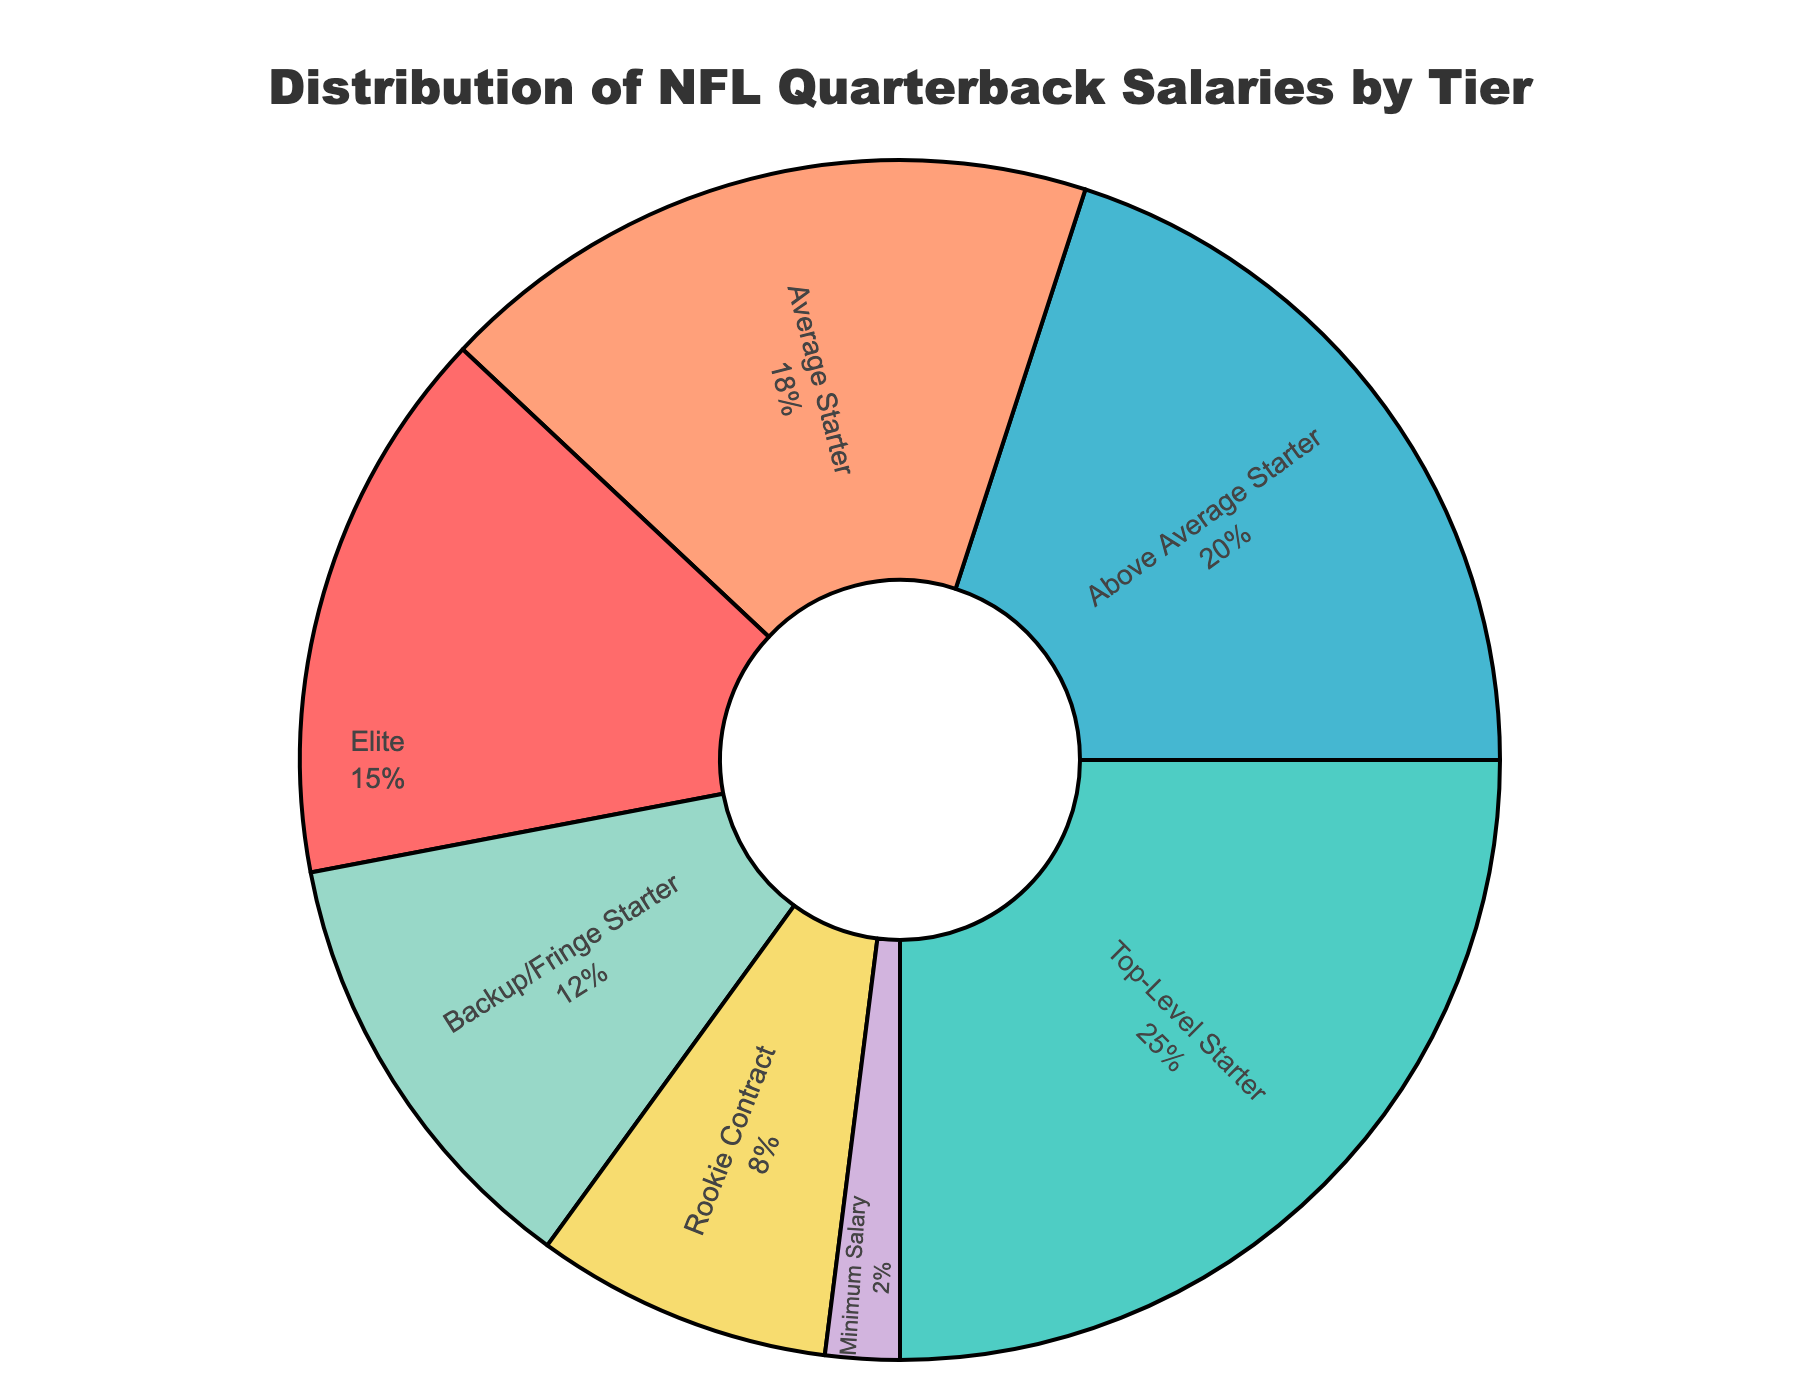What percentage of quarterbacks earn elite salaries? The segment labeled "Elite" represents 15% of the total quarterback salaries. We can observe this by looking at the segment labeled "Elite" in the pie chart.
Answer: 15% Which tier has the highest percentage of quarterback salaries? The segment labeled "Top-Level Starter" has the largest section of the pie chart, representing 25% of the total quarterback salaries. This is the highest percentage among all segments.
Answer: Top-Level Starter What is the combined percentage of quarterbacks earning rookie contract and minimum salary? The "Rookie Contract" segment represents 8% and "Minimum Salary" segment represents 2%. Adding these percentages together, we get 8% + 2% = 10%.
Answer: 10% How much more is the percentage of top-level starters compared to backup/fringe starters? The "Top-Level Starter" segment represents 25%, while the "Backup/Fringe Starter" segment represents 12%. Subtracting these, we get 25% - 12% = 13%.
Answer: 13% What percentage of quarterbacks earn salaries as above-average starters and average starters combined? The segments for "Above Average Starter" and "Average Starter" represent 20% and 18% respectively. Adding these percentages together, we get 20% + 18% = 38%.
Answer: 38% Which player is an example of an average starter, and what is the percentage of quarterbacks in this tier? The "Average Starter" segment is represented by 18%, and the example player for this tier is Jimmy Garoppolo, as labeled on the pie chart.
Answer: Jimmy Garoppolo, 18% Which tier has the smallest percentage of quarterback salaries? The "Minimum Salary" segment has the smallest section of the pie chart, representing only 2% of the total quarterback salaries.
Answer: Minimum Salary Is the total percentage of quarterbacks earning salaries below above-average starter higher or lower than those earning above-average starter or higher? The percentages for tiers below above-average starter (Average Starter, Backup/Fringe Starter, Rookie Contract, and Minimum Salary) are 18%, 12%, 8%, and 2%. Their total is 18% + 12% + 8% + 2% = 40%. The tiers above-average starter or higher (Elite, Top-Level Starter, and Above Average Starter) are 15%, 25%, and 20%. Their total is 15% + 25% + 20% = 60%. Comparing these, 40% is less than 60%.
Answer: Lower Which segment is represented by a light green color, and what percentage does it cover? The segment represented by a light green color corresponds to the "Backup/Fringe Starter" tier and covers 12% of the pie chart.
Answer: Backup/Fringe Starter, 12% What is the difference between the percentage of quarterbacks earning elite salaries and those earning rookie contract salaries? The "Elite" segment represents 15% and the "Rookie Contract" segment represents 8%. The difference is 15% - 8% = 7%.
Answer: 7% 